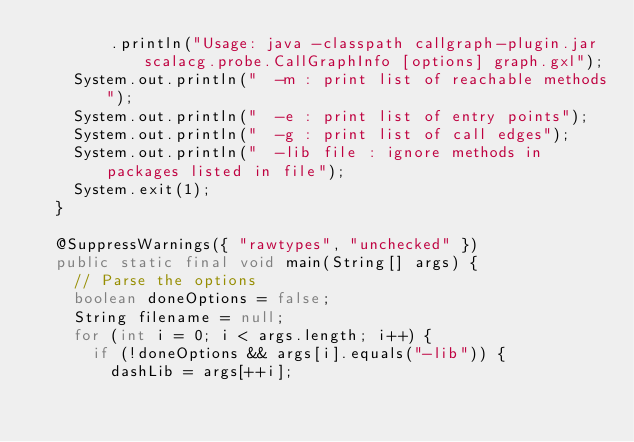<code> <loc_0><loc_0><loc_500><loc_500><_Java_>				.println("Usage: java -classpath callgraph-plugin.jar scalacg.probe.CallGraphInfo [options] graph.gxl");
		System.out.println("  -m : print list of reachable methods");
		System.out.println("  -e : print list of entry points");
		System.out.println("  -g : print list of call edges");
		System.out.println("  -lib file : ignore methods in packages listed in file");
		System.exit(1);
	}

	@SuppressWarnings({ "rawtypes", "unchecked" })
	public static final void main(String[] args) {
		// Parse the options
		boolean doneOptions = false;
		String filename = null;
		for (int i = 0; i < args.length; i++) {
			if (!doneOptions && args[i].equals("-lib")) {
				dashLib = args[++i];</code> 